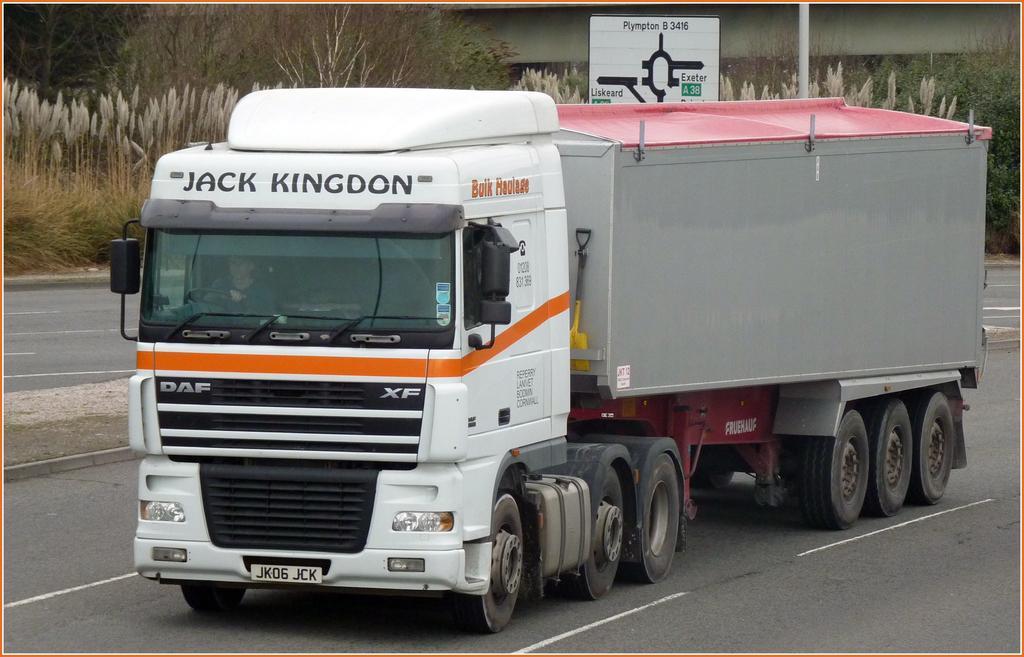In one or two sentences, can you explain what this image depicts? In this image we can see truck on the road. In the back there is a sign board. Also there are trees and there are plants. 